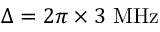<formula> <loc_0><loc_0><loc_500><loc_500>\Delta = 2 \pi \times 3 M H z</formula> 